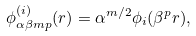<formula> <loc_0><loc_0><loc_500><loc_500>\phi _ { \alpha \beta m p } ^ { ( i ) } ( r ) = \alpha ^ { m / 2 } \phi _ { i } ( \beta ^ { p } r ) ,</formula> 